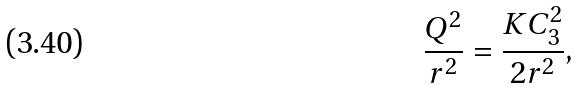<formula> <loc_0><loc_0><loc_500><loc_500>\frac { Q ^ { 2 } } { r ^ { 2 } } = \frac { K C _ { 3 } ^ { 2 } } { 2 r ^ { 2 } } ,</formula> 